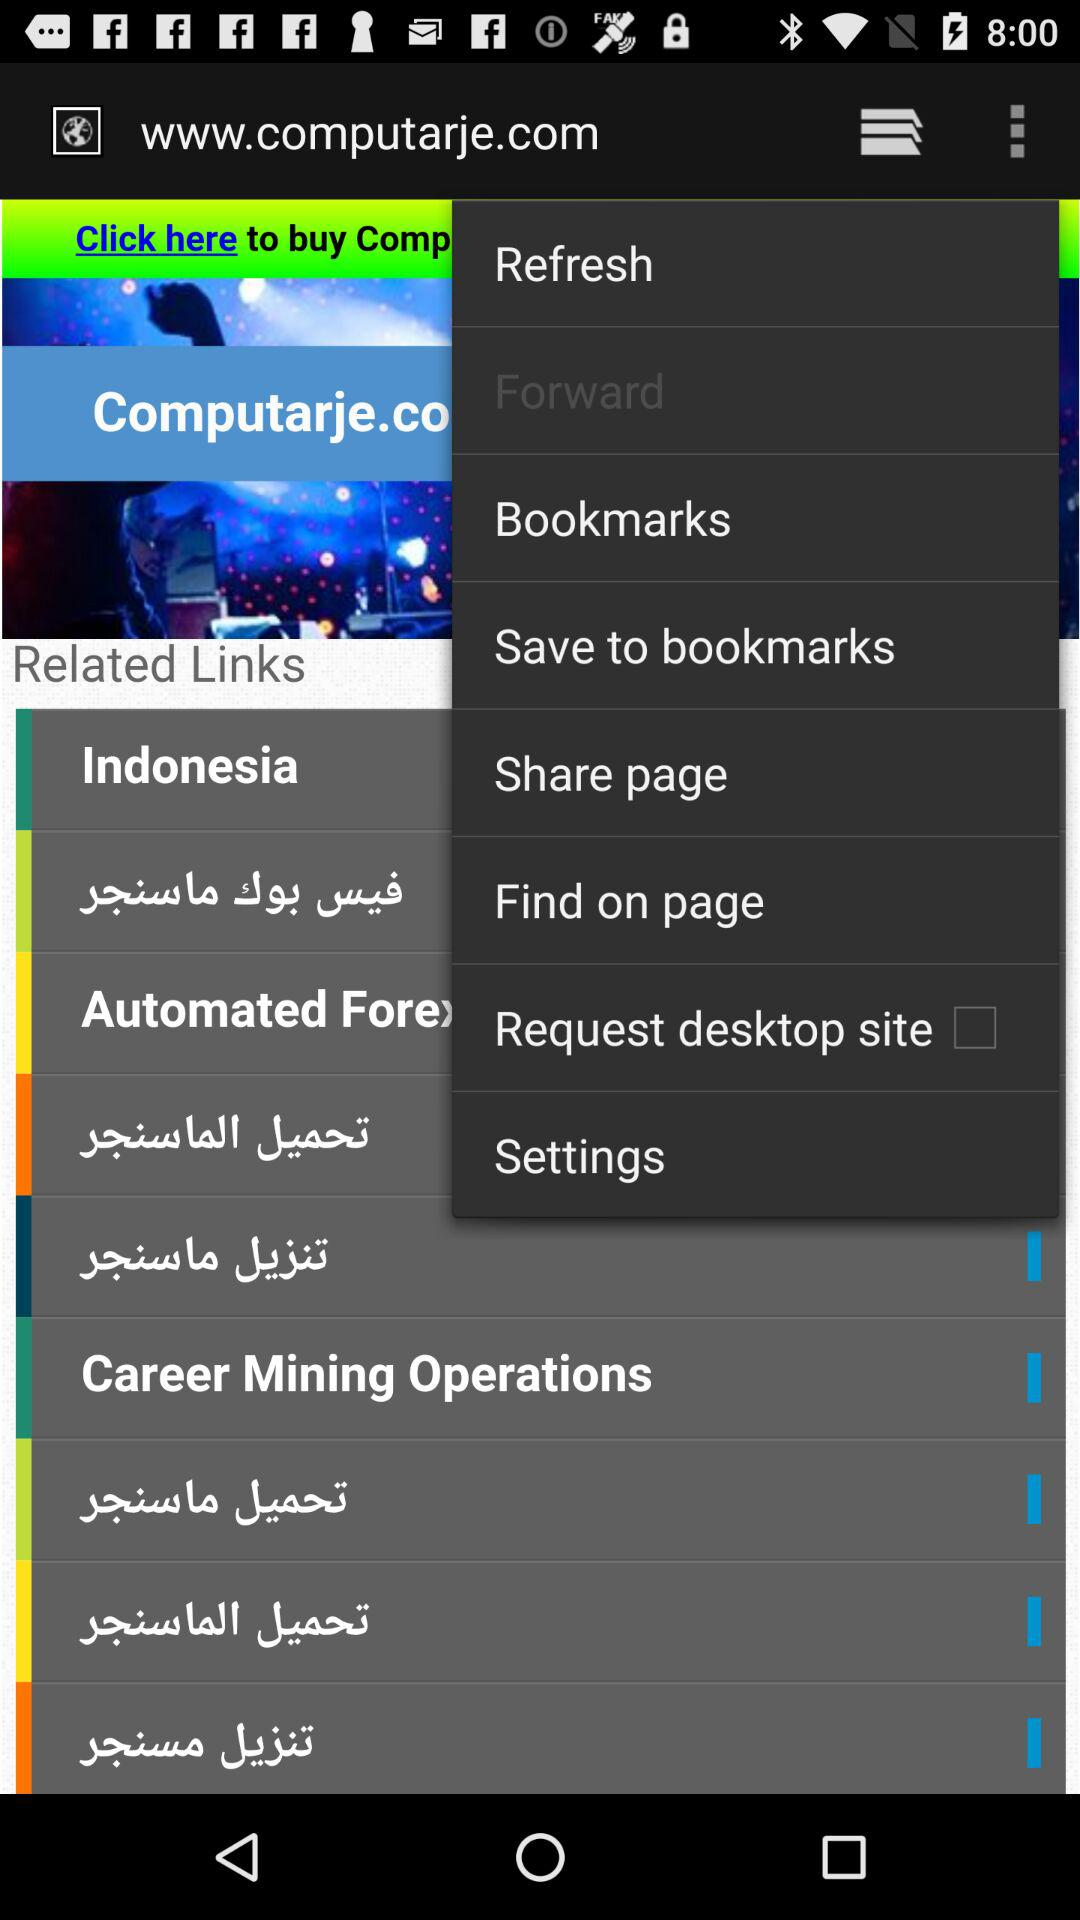What is the name of application?
When the provided information is insufficient, respond with <no answer>. <no answer> 